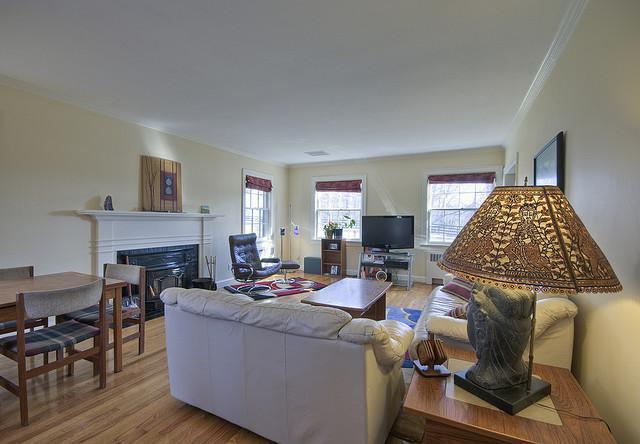How many windows are there?
Give a very brief answer. 3. How many couches are visible?
Give a very brief answer. 2. How many chairs are visible?
Give a very brief answer. 2. How many cars have headlights on?
Give a very brief answer. 0. 